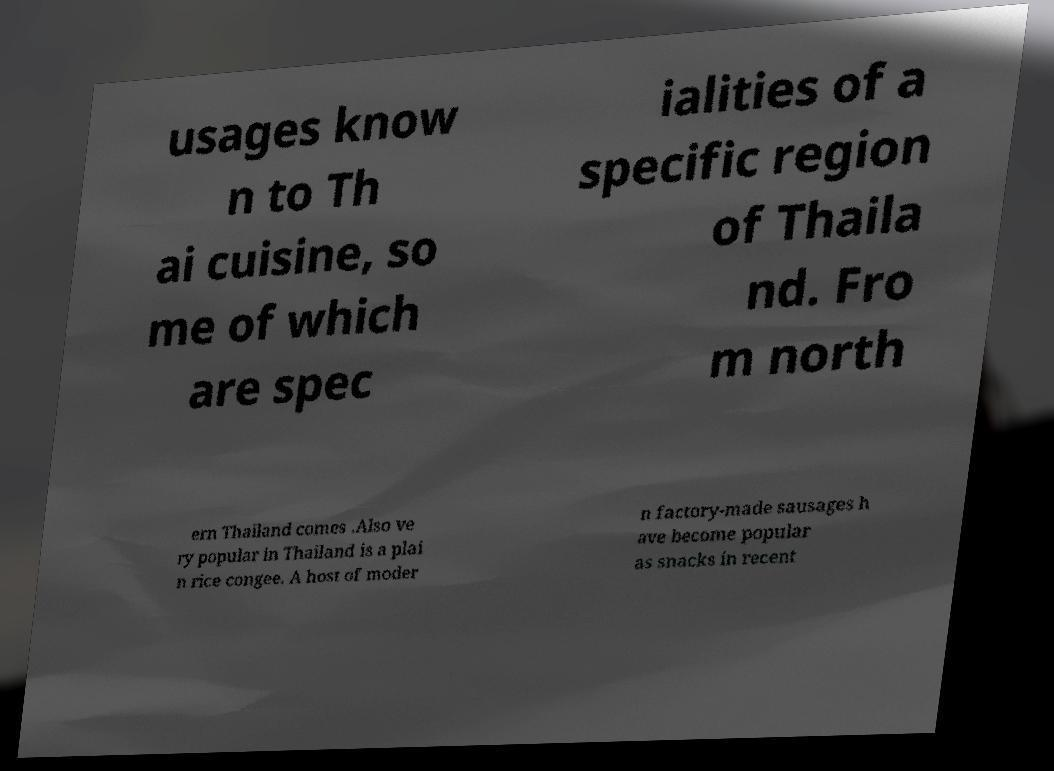Could you extract and type out the text from this image? usages know n to Th ai cuisine, so me of which are spec ialities of a specific region of Thaila nd. Fro m north ern Thailand comes .Also ve ry popular in Thailand is a plai n rice congee. A host of moder n factory-made sausages h ave become popular as snacks in recent 